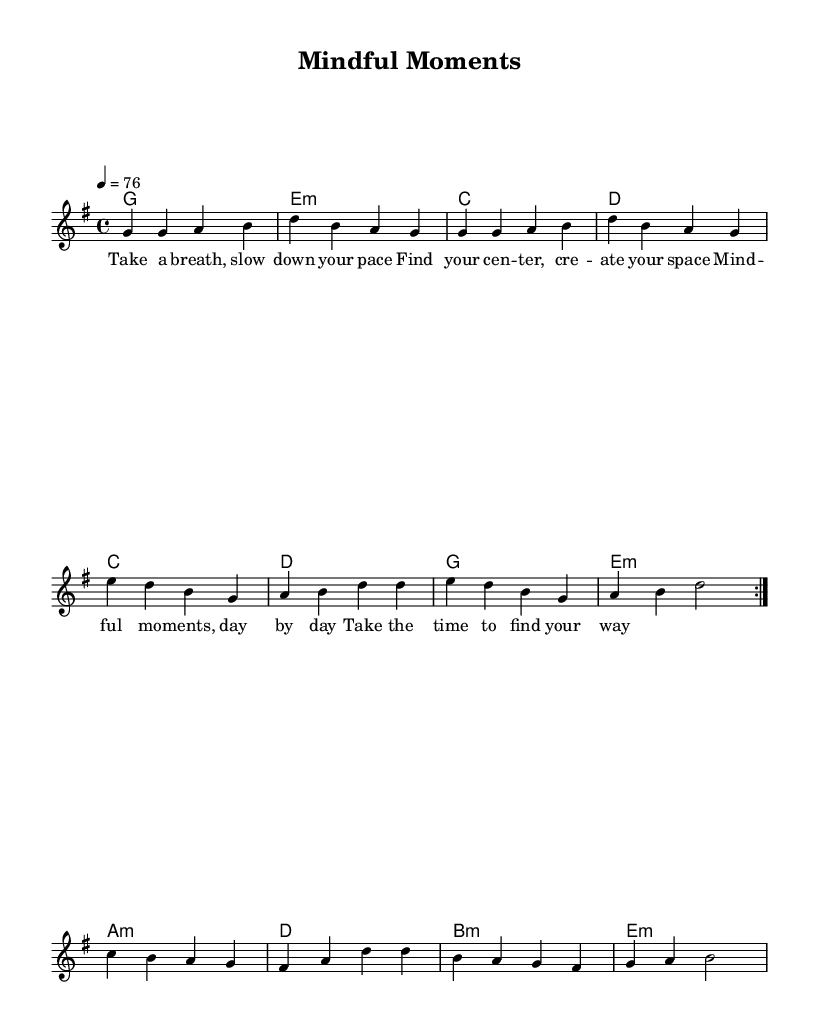What is the key signature of this music? The sheet music indicates that the piece is in G major, which has one sharp (F#). This is observable in the header section labeled 'global' where the key is defined.
Answer: G major What is the time signature of the music? The time signature appears in the global settings of the music where it is stated as 4/4. This means there are four beats in a measure and the quarter note gets one beat.
Answer: 4/4 What is the tempo marking for the piece? The tempo marking is stated as '4 = 76' in the global section, signifying that there are 76 beats per minute. This informs the performer about the speed of the piece.
Answer: 76 How many times is the first section repeated in the melody? The melody specifies a repeat indication with the phrase 'repeat volta 2', showing that this section is played twice.
Answer: 2 What are the first two words of the lyrics? The lyrics start with the words "Take a," which can be found at the beginning of the lyric section labeled 'verseOne'.
Answer: Take a Which chord follows the first repeating section? After the repeated section of the harmonies, the next chord is A minor as indicated by the chord mode section in the sheet music following the repeats.
Answer: A minor How many unique chords are used in the harmony section? By analyzing the chord progression in the harmony part, we can see that it includes G, E minor, C, D, A minor, B minor, and E minor, resulting in a total of 7 unique chords.
Answer: 7 